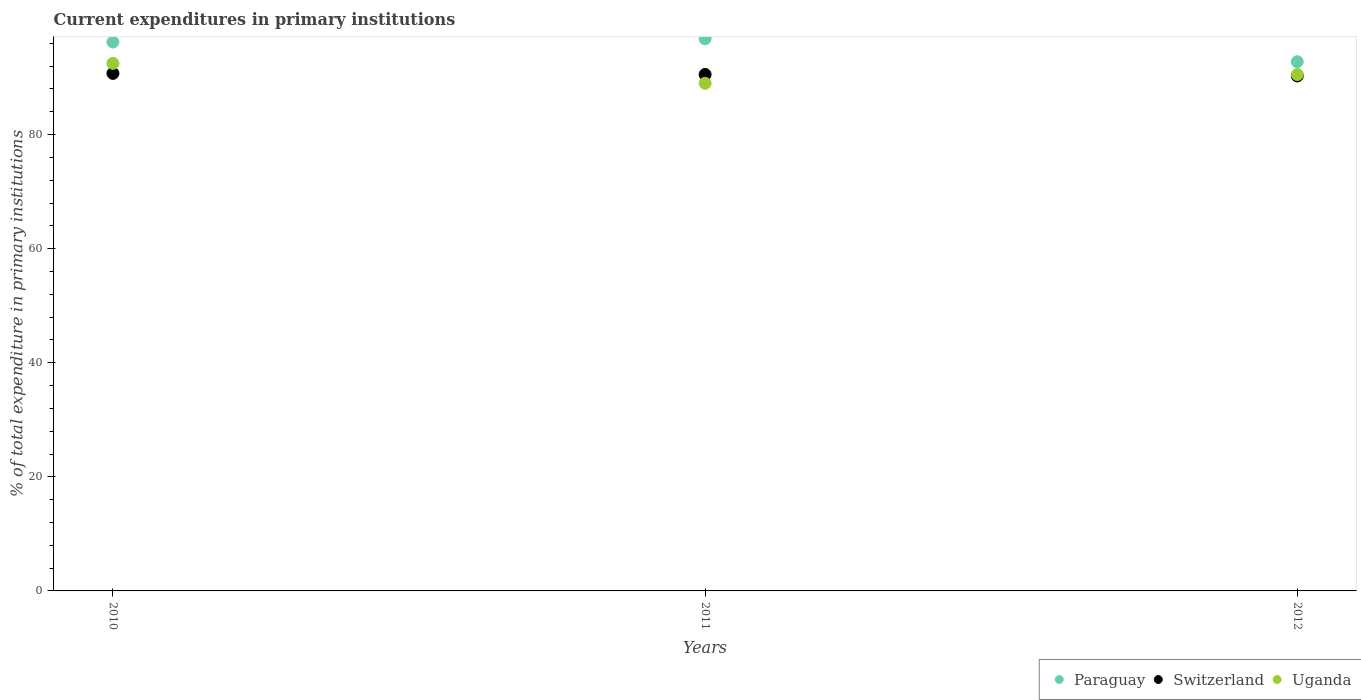Is the number of dotlines equal to the number of legend labels?
Offer a terse response. Yes. What is the current expenditures in primary institutions in Switzerland in 2012?
Make the answer very short. 90.28. Across all years, what is the maximum current expenditures in primary institutions in Switzerland?
Provide a succinct answer. 90.73. Across all years, what is the minimum current expenditures in primary institutions in Switzerland?
Give a very brief answer. 90.28. In which year was the current expenditures in primary institutions in Paraguay maximum?
Your response must be concise. 2011. In which year was the current expenditures in primary institutions in Paraguay minimum?
Make the answer very short. 2012. What is the total current expenditures in primary institutions in Uganda in the graph?
Offer a very short reply. 271.99. What is the difference between the current expenditures in primary institutions in Switzerland in 2010 and that in 2011?
Provide a succinct answer. 0.19. What is the difference between the current expenditures in primary institutions in Uganda in 2011 and the current expenditures in primary institutions in Switzerland in 2012?
Your answer should be very brief. -1.29. What is the average current expenditures in primary institutions in Uganda per year?
Your response must be concise. 90.66. In the year 2012, what is the difference between the current expenditures in primary institutions in Switzerland and current expenditures in primary institutions in Paraguay?
Offer a very short reply. -2.49. What is the ratio of the current expenditures in primary institutions in Switzerland in 2010 to that in 2011?
Offer a very short reply. 1. Is the current expenditures in primary institutions in Paraguay in 2010 less than that in 2012?
Your response must be concise. No. Is the difference between the current expenditures in primary institutions in Switzerland in 2010 and 2012 greater than the difference between the current expenditures in primary institutions in Paraguay in 2010 and 2012?
Provide a succinct answer. No. What is the difference between the highest and the second highest current expenditures in primary institutions in Paraguay?
Provide a short and direct response. 0.57. What is the difference between the highest and the lowest current expenditures in primary institutions in Paraguay?
Offer a very short reply. 4.02. Is the sum of the current expenditures in primary institutions in Paraguay in 2011 and 2012 greater than the maximum current expenditures in primary institutions in Uganda across all years?
Provide a short and direct response. Yes. Is it the case that in every year, the sum of the current expenditures in primary institutions in Uganda and current expenditures in primary institutions in Switzerland  is greater than the current expenditures in primary institutions in Paraguay?
Provide a succinct answer. Yes. Does the current expenditures in primary institutions in Uganda monotonically increase over the years?
Keep it short and to the point. No. Is the current expenditures in primary institutions in Uganda strictly greater than the current expenditures in primary institutions in Switzerland over the years?
Make the answer very short. No. How many dotlines are there?
Provide a succinct answer. 3. Are the values on the major ticks of Y-axis written in scientific E-notation?
Offer a very short reply. No. Does the graph contain grids?
Give a very brief answer. No. Where does the legend appear in the graph?
Your response must be concise. Bottom right. How many legend labels are there?
Your answer should be compact. 3. What is the title of the graph?
Make the answer very short. Current expenditures in primary institutions. Does "Albania" appear as one of the legend labels in the graph?
Keep it short and to the point. No. What is the label or title of the X-axis?
Your answer should be very brief. Years. What is the label or title of the Y-axis?
Provide a succinct answer. % of total expenditure in primary institutions. What is the % of total expenditure in primary institutions in Paraguay in 2010?
Ensure brevity in your answer.  96.22. What is the % of total expenditure in primary institutions in Switzerland in 2010?
Give a very brief answer. 90.73. What is the % of total expenditure in primary institutions of Uganda in 2010?
Ensure brevity in your answer.  92.48. What is the % of total expenditure in primary institutions of Paraguay in 2011?
Your response must be concise. 96.79. What is the % of total expenditure in primary institutions of Switzerland in 2011?
Offer a terse response. 90.54. What is the % of total expenditure in primary institutions in Uganda in 2011?
Give a very brief answer. 88.99. What is the % of total expenditure in primary institutions of Paraguay in 2012?
Provide a short and direct response. 92.77. What is the % of total expenditure in primary institutions of Switzerland in 2012?
Offer a terse response. 90.28. What is the % of total expenditure in primary institutions in Uganda in 2012?
Keep it short and to the point. 90.52. Across all years, what is the maximum % of total expenditure in primary institutions in Paraguay?
Your answer should be compact. 96.79. Across all years, what is the maximum % of total expenditure in primary institutions in Switzerland?
Provide a short and direct response. 90.73. Across all years, what is the maximum % of total expenditure in primary institutions of Uganda?
Give a very brief answer. 92.48. Across all years, what is the minimum % of total expenditure in primary institutions of Paraguay?
Your response must be concise. 92.77. Across all years, what is the minimum % of total expenditure in primary institutions of Switzerland?
Ensure brevity in your answer.  90.28. Across all years, what is the minimum % of total expenditure in primary institutions of Uganda?
Your answer should be compact. 88.99. What is the total % of total expenditure in primary institutions in Paraguay in the graph?
Your response must be concise. 285.78. What is the total % of total expenditure in primary institutions of Switzerland in the graph?
Ensure brevity in your answer.  271.54. What is the total % of total expenditure in primary institutions of Uganda in the graph?
Offer a terse response. 271.99. What is the difference between the % of total expenditure in primary institutions of Paraguay in 2010 and that in 2011?
Your answer should be compact. -0.57. What is the difference between the % of total expenditure in primary institutions in Switzerland in 2010 and that in 2011?
Ensure brevity in your answer.  0.19. What is the difference between the % of total expenditure in primary institutions in Uganda in 2010 and that in 2011?
Your response must be concise. 3.49. What is the difference between the % of total expenditure in primary institutions of Paraguay in 2010 and that in 2012?
Make the answer very short. 3.45. What is the difference between the % of total expenditure in primary institutions in Switzerland in 2010 and that in 2012?
Offer a terse response. 0.45. What is the difference between the % of total expenditure in primary institutions in Uganda in 2010 and that in 2012?
Keep it short and to the point. 1.96. What is the difference between the % of total expenditure in primary institutions in Paraguay in 2011 and that in 2012?
Your answer should be compact. 4.02. What is the difference between the % of total expenditure in primary institutions in Switzerland in 2011 and that in 2012?
Provide a short and direct response. 0.26. What is the difference between the % of total expenditure in primary institutions of Uganda in 2011 and that in 2012?
Keep it short and to the point. -1.53. What is the difference between the % of total expenditure in primary institutions of Paraguay in 2010 and the % of total expenditure in primary institutions of Switzerland in 2011?
Offer a terse response. 5.69. What is the difference between the % of total expenditure in primary institutions in Paraguay in 2010 and the % of total expenditure in primary institutions in Uganda in 2011?
Offer a terse response. 7.23. What is the difference between the % of total expenditure in primary institutions in Switzerland in 2010 and the % of total expenditure in primary institutions in Uganda in 2011?
Your response must be concise. 1.74. What is the difference between the % of total expenditure in primary institutions of Paraguay in 2010 and the % of total expenditure in primary institutions of Switzerland in 2012?
Give a very brief answer. 5.94. What is the difference between the % of total expenditure in primary institutions of Paraguay in 2010 and the % of total expenditure in primary institutions of Uganda in 2012?
Your answer should be very brief. 5.7. What is the difference between the % of total expenditure in primary institutions in Switzerland in 2010 and the % of total expenditure in primary institutions in Uganda in 2012?
Provide a succinct answer. 0.21. What is the difference between the % of total expenditure in primary institutions of Paraguay in 2011 and the % of total expenditure in primary institutions of Switzerland in 2012?
Ensure brevity in your answer.  6.51. What is the difference between the % of total expenditure in primary institutions in Paraguay in 2011 and the % of total expenditure in primary institutions in Uganda in 2012?
Your answer should be very brief. 6.27. What is the difference between the % of total expenditure in primary institutions in Switzerland in 2011 and the % of total expenditure in primary institutions in Uganda in 2012?
Your answer should be compact. 0.02. What is the average % of total expenditure in primary institutions of Paraguay per year?
Your answer should be compact. 95.26. What is the average % of total expenditure in primary institutions of Switzerland per year?
Your response must be concise. 90.51. What is the average % of total expenditure in primary institutions in Uganda per year?
Your answer should be compact. 90.66. In the year 2010, what is the difference between the % of total expenditure in primary institutions of Paraguay and % of total expenditure in primary institutions of Switzerland?
Your answer should be compact. 5.49. In the year 2010, what is the difference between the % of total expenditure in primary institutions in Paraguay and % of total expenditure in primary institutions in Uganda?
Keep it short and to the point. 3.74. In the year 2010, what is the difference between the % of total expenditure in primary institutions of Switzerland and % of total expenditure in primary institutions of Uganda?
Offer a terse response. -1.76. In the year 2011, what is the difference between the % of total expenditure in primary institutions of Paraguay and % of total expenditure in primary institutions of Switzerland?
Give a very brief answer. 6.25. In the year 2011, what is the difference between the % of total expenditure in primary institutions in Paraguay and % of total expenditure in primary institutions in Uganda?
Ensure brevity in your answer.  7.8. In the year 2011, what is the difference between the % of total expenditure in primary institutions of Switzerland and % of total expenditure in primary institutions of Uganda?
Give a very brief answer. 1.54. In the year 2012, what is the difference between the % of total expenditure in primary institutions of Paraguay and % of total expenditure in primary institutions of Switzerland?
Your answer should be compact. 2.49. In the year 2012, what is the difference between the % of total expenditure in primary institutions in Paraguay and % of total expenditure in primary institutions in Uganda?
Your answer should be compact. 2.25. In the year 2012, what is the difference between the % of total expenditure in primary institutions in Switzerland and % of total expenditure in primary institutions in Uganda?
Provide a short and direct response. -0.24. What is the ratio of the % of total expenditure in primary institutions in Switzerland in 2010 to that in 2011?
Your answer should be very brief. 1. What is the ratio of the % of total expenditure in primary institutions in Uganda in 2010 to that in 2011?
Provide a short and direct response. 1.04. What is the ratio of the % of total expenditure in primary institutions in Paraguay in 2010 to that in 2012?
Offer a terse response. 1.04. What is the ratio of the % of total expenditure in primary institutions in Uganda in 2010 to that in 2012?
Your response must be concise. 1.02. What is the ratio of the % of total expenditure in primary institutions of Paraguay in 2011 to that in 2012?
Make the answer very short. 1.04. What is the ratio of the % of total expenditure in primary institutions of Uganda in 2011 to that in 2012?
Provide a succinct answer. 0.98. What is the difference between the highest and the second highest % of total expenditure in primary institutions in Paraguay?
Keep it short and to the point. 0.57. What is the difference between the highest and the second highest % of total expenditure in primary institutions in Switzerland?
Keep it short and to the point. 0.19. What is the difference between the highest and the second highest % of total expenditure in primary institutions of Uganda?
Ensure brevity in your answer.  1.96. What is the difference between the highest and the lowest % of total expenditure in primary institutions in Paraguay?
Your answer should be compact. 4.02. What is the difference between the highest and the lowest % of total expenditure in primary institutions of Switzerland?
Your answer should be compact. 0.45. What is the difference between the highest and the lowest % of total expenditure in primary institutions in Uganda?
Make the answer very short. 3.49. 